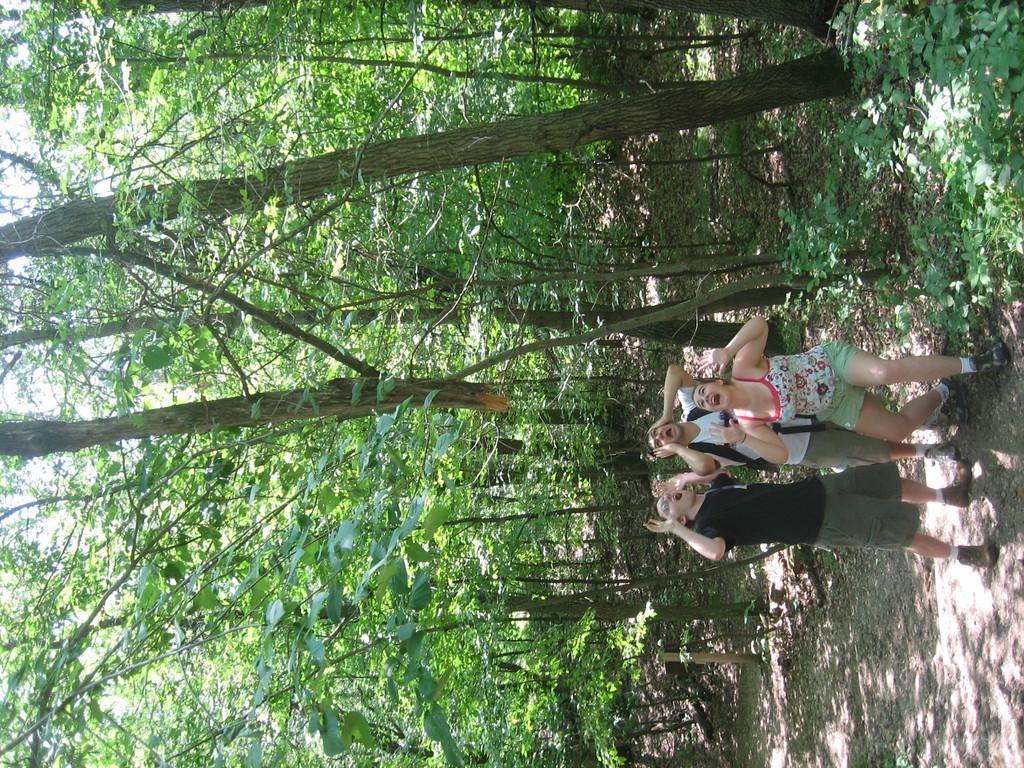How many people are in the image? There are three people in the image. What are the people doing in the image? The people are standing and shouting. What can be seen in the background of the image? There are trees visible in the background of the image. What type of road can be seen in the image? There is no road visible in the image; it only shows three people standing and shouting with trees in the background. 